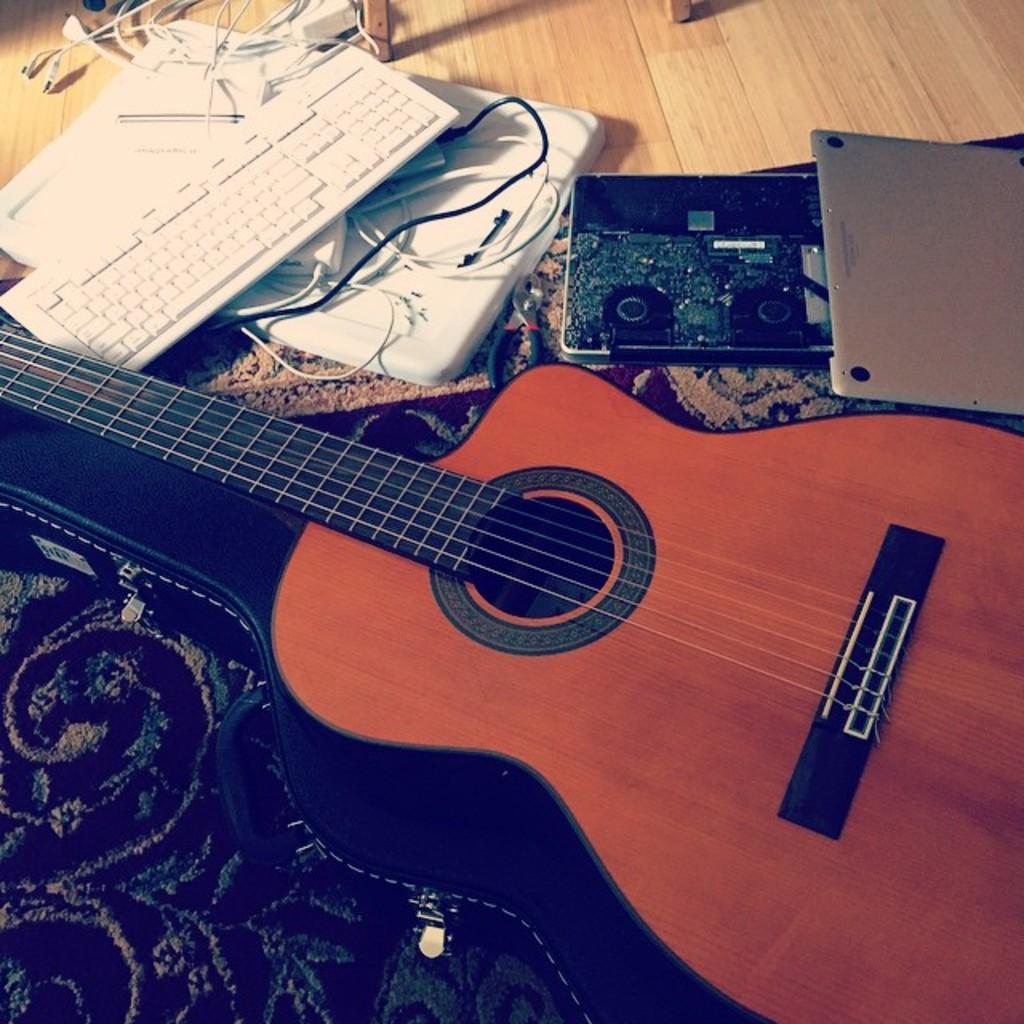Describe this image in one or two sentences. In this Image I see a guitar, keyboard, wires and other equipment and I also see the cloth. 